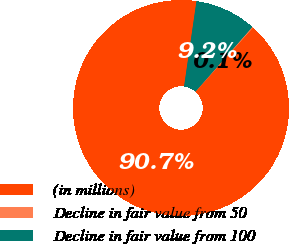Convert chart to OTSL. <chart><loc_0><loc_0><loc_500><loc_500><pie_chart><fcel>(in millions)<fcel>Decline in fair value from 50<fcel>Decline in fair value from 100<nl><fcel>90.68%<fcel>0.14%<fcel>9.19%<nl></chart> 